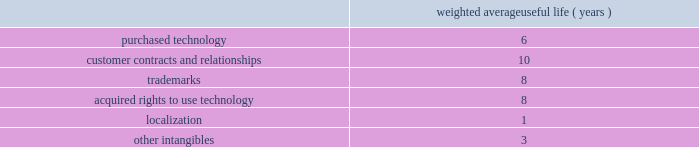Adobe systems incorporated notes to consolidated financial statements ( continued ) we review our goodwill for impairment annually , or more frequently , if facts and circumstances warrant a review .
We completed our annual impairment test in the second quarter of fiscal 2014 .
We elected to use the step 1 quantitative assessment for our reporting units and determined that there was no impairment of goodwill .
There is no significant risk of material goodwill impairment in any of our reporting units , based upon the results of our annual goodwill impairment test .
We amortize intangible assets with finite lives over their estimated useful lives and review them for impairment whenever an impairment indicator exists .
We continually monitor events and changes in circumstances that could indicate carrying amounts of our long-lived assets , including our intangible assets may not be recoverable .
When such events or changes in circumstances occur , we assess recoverability by determining whether the carrying value of such assets will be recovered through the undiscounted expected future cash flows .
If the future undiscounted cash flows are less than the carrying amount of these assets , we recognize an impairment loss based on any excess of the carrying amount over the fair value of the assets .
We did not recognize any intangible asset impairment charges in fiscal 2014 , 2013 or 2012 .
Our intangible assets are amortized over their estimated useful lives of 1 to 14 years .
Amortization is based on the pattern in which the economic benefits of the intangible asset will be consumed or on a straight-line basis when the consumption pattern is not apparent .
The weighted average useful lives of our intangible assets were as follows : weighted average useful life ( years ) .
Software development costs capitalization of software development costs for software to be sold , leased , or otherwise marketed begins upon the establishment of technological feasibility , which is generally the completion of a working prototype that has been certified as having no critical bugs and is a release candidate .
Amortization begins once the software is ready for its intended use , generally based on the pattern in which the economic benefits will be consumed .
To date , software development costs incurred between completion of a working prototype and general availability of the related product have not been material .
Internal use software we capitalize costs associated with customized internal-use software systems that have reached the application development stage .
Such capitalized costs include external direct costs utilized in developing or obtaining the applications and payroll and payroll-related expenses for employees , who are directly associated with the development of the applications .
Capitalization of such costs begins when the preliminary project stage is complete and ceases at the point in which the project is substantially complete and is ready for its intended purpose .
Income taxes we use the asset and liability method of accounting for income taxes .
Under this method , income tax expense is recognized for the amount of taxes payable or refundable for the current year .
In addition , deferred tax assets and liabilities are recognized for expected future tax consequences of temporary differences between the financial reporting and tax bases of assets and liabilities , and for operating losses and tax credit carryforwards .
We record a valuation allowance to reduce deferred tax assets to an amount for which realization is more likely than not .
Taxes collected from customers we net taxes collected from customers against those remitted to government authorities in our financial statements .
Accordingly , taxes collected from customers are not reported as revenue. .
Is the weighted average useful life ( years ) greater for acquired rights to use technology than localization? 
Computations: (8 > 1)
Answer: yes. 